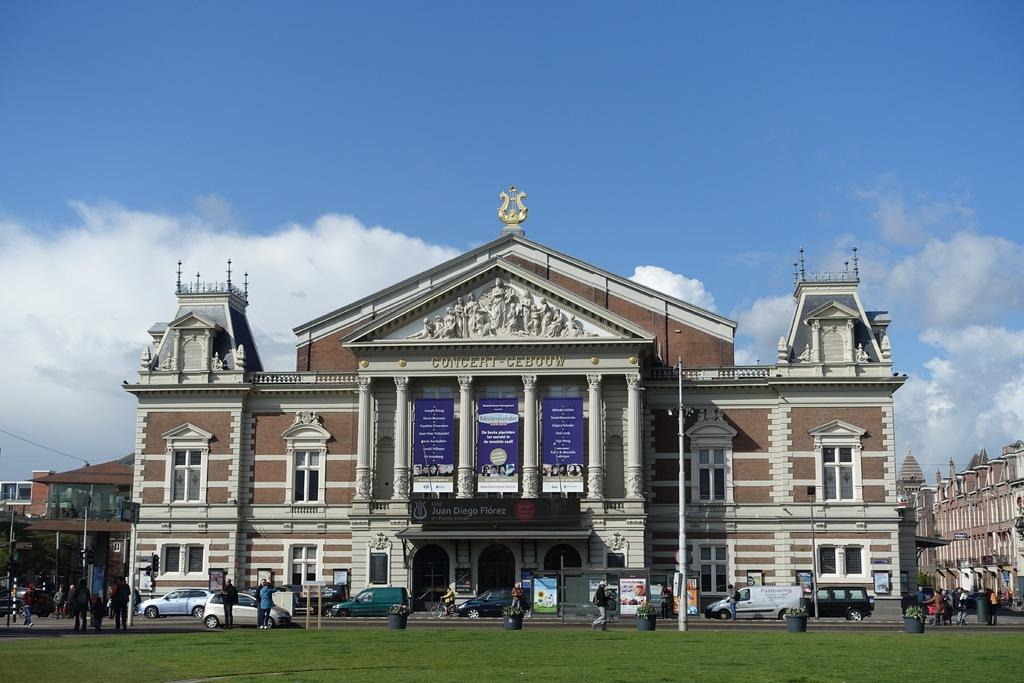What type of structures can be seen in the image? There are buildings in the image. What are the people in the image doing? People are walking on the road in the image. What is in the foreground of the image? There is grass in the foreground of the image. What type of decorative containers are present in the image? There are flower pots in the image. What can be seen in the sky in the image? There are clouds visible in the sky. Can you tell me how many times the people in the image attempted to fly an airplane? There is no airplane present in the image, and therefore no such attempt can be observed. What point in the image is the tallest building located? The provided facts do not specify the location of the tallest building in the image, so it cannot be determined. 